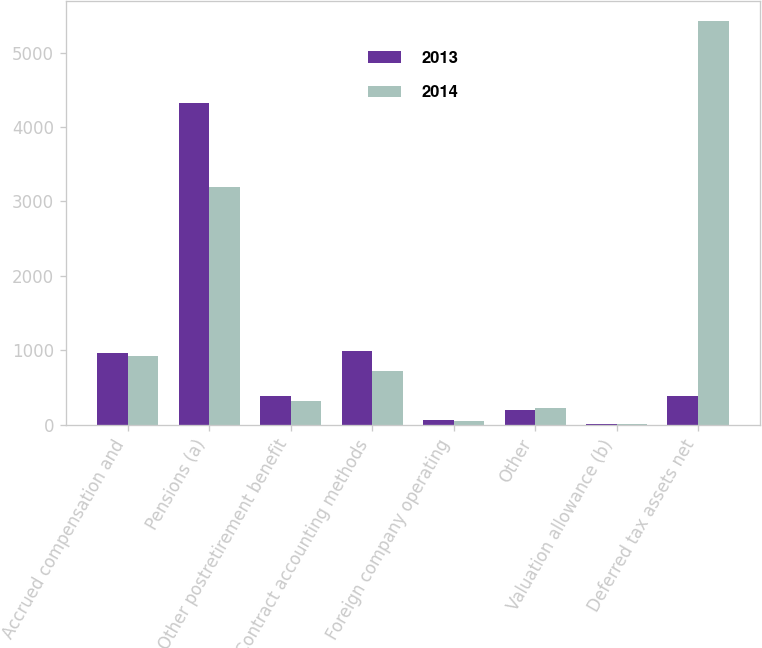<chart> <loc_0><loc_0><loc_500><loc_500><stacked_bar_chart><ecel><fcel>Accrued compensation and<fcel>Pensions (a)<fcel>Other postretirement benefit<fcel>Contract accounting methods<fcel>Foreign company operating<fcel>Other<fcel>Valuation allowance (b)<fcel>Deferred tax assets net<nl><fcel>2013<fcel>965<fcel>4317<fcel>386<fcel>989<fcel>59<fcel>198<fcel>9<fcel>386<nl><fcel>2014<fcel>918<fcel>3198<fcel>316<fcel>721<fcel>52<fcel>223<fcel>8<fcel>5420<nl></chart> 